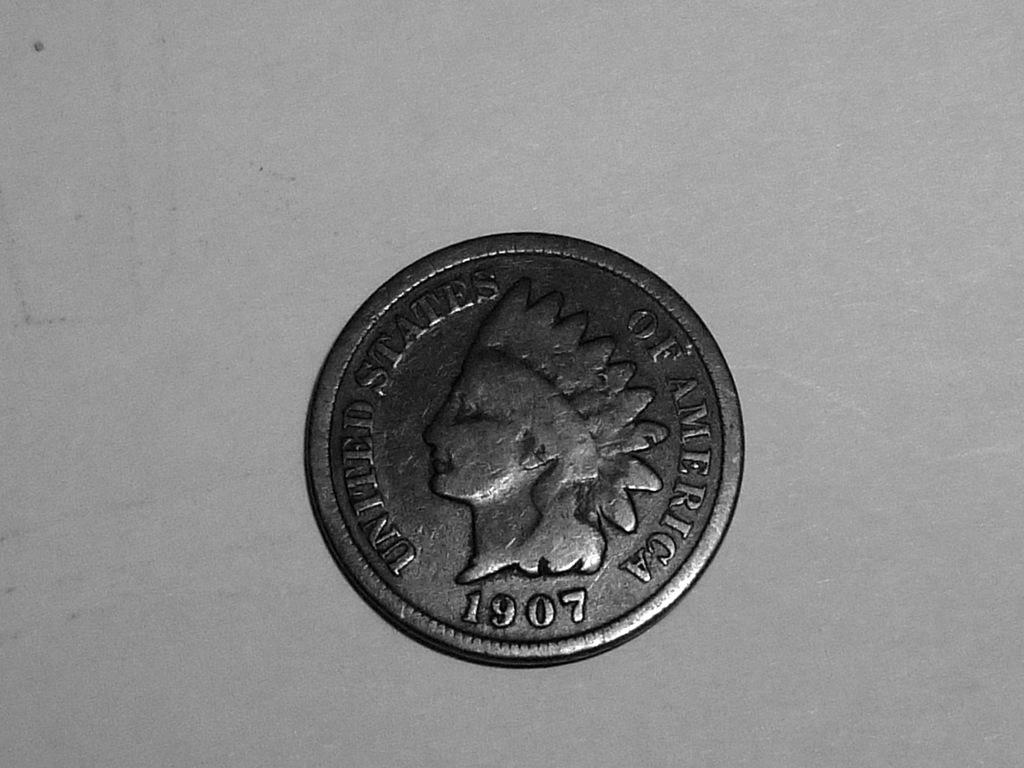<image>
Present a compact description of the photo's key features. A coin with United States of America 1907 is laying on a flat surface. 